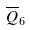Convert formula to latex. <formula><loc_0><loc_0><loc_500><loc_500>\overline { Q } _ { 6 }</formula> 